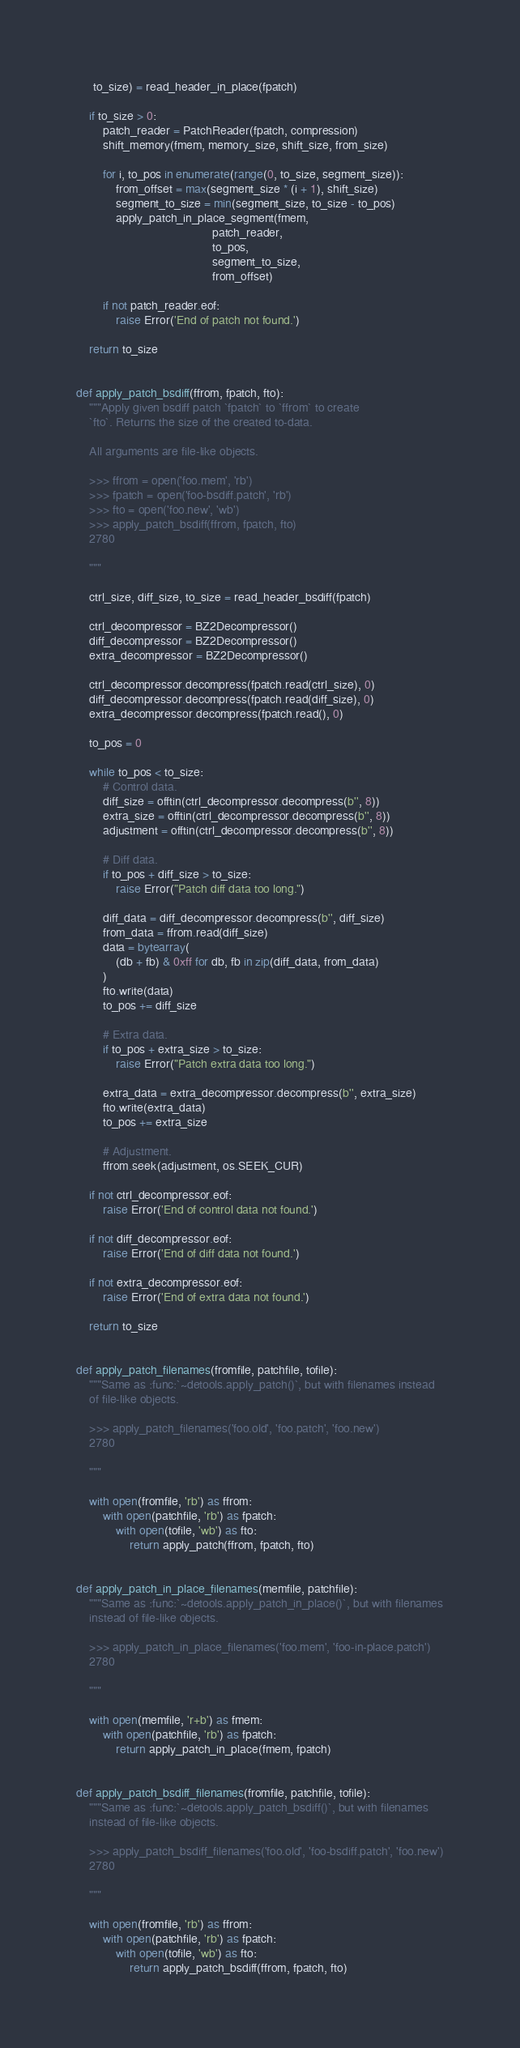Convert code to text. <code><loc_0><loc_0><loc_500><loc_500><_Python_>     to_size) = read_header_in_place(fpatch)

    if to_size > 0:
        patch_reader = PatchReader(fpatch, compression)
        shift_memory(fmem, memory_size, shift_size, from_size)

        for i, to_pos in enumerate(range(0, to_size, segment_size)):
            from_offset = max(segment_size * (i + 1), shift_size)
            segment_to_size = min(segment_size, to_size - to_pos)
            apply_patch_in_place_segment(fmem,
                                         patch_reader,
                                         to_pos,
                                         segment_to_size,
                                         from_offset)

        if not patch_reader.eof:
            raise Error('End of patch not found.')

    return to_size


def apply_patch_bsdiff(ffrom, fpatch, fto):
    """Apply given bsdiff patch `fpatch` to `ffrom` to create
    `fto`. Returns the size of the created to-data.

    All arguments are file-like objects.

    >>> ffrom = open('foo.mem', 'rb')
    >>> fpatch = open('foo-bsdiff.patch', 'rb')
    >>> fto = open('foo.new', 'wb')
    >>> apply_patch_bsdiff(ffrom, fpatch, fto)
    2780

    """

    ctrl_size, diff_size, to_size = read_header_bsdiff(fpatch)

    ctrl_decompressor = BZ2Decompressor()
    diff_decompressor = BZ2Decompressor()
    extra_decompressor = BZ2Decompressor()

    ctrl_decompressor.decompress(fpatch.read(ctrl_size), 0)
    diff_decompressor.decompress(fpatch.read(diff_size), 0)
    extra_decompressor.decompress(fpatch.read(), 0)

    to_pos = 0

    while to_pos < to_size:
        # Control data.
        diff_size = offtin(ctrl_decompressor.decompress(b'', 8))
        extra_size = offtin(ctrl_decompressor.decompress(b'', 8))
        adjustment = offtin(ctrl_decompressor.decompress(b'', 8))

        # Diff data.
        if to_pos + diff_size > to_size:
            raise Error("Patch diff data too long.")

        diff_data = diff_decompressor.decompress(b'', diff_size)
        from_data = ffrom.read(diff_size)
        data = bytearray(
            (db + fb) & 0xff for db, fb in zip(diff_data, from_data)
        )
        fto.write(data)
        to_pos += diff_size

        # Extra data.
        if to_pos + extra_size > to_size:
            raise Error("Patch extra data too long.")

        extra_data = extra_decompressor.decompress(b'', extra_size)
        fto.write(extra_data)
        to_pos += extra_size

        # Adjustment.
        ffrom.seek(adjustment, os.SEEK_CUR)

    if not ctrl_decompressor.eof:
        raise Error('End of control data not found.')

    if not diff_decompressor.eof:
        raise Error('End of diff data not found.')

    if not extra_decompressor.eof:
        raise Error('End of extra data not found.')

    return to_size


def apply_patch_filenames(fromfile, patchfile, tofile):
    """Same as :func:`~detools.apply_patch()`, but with filenames instead
    of file-like objects.

    >>> apply_patch_filenames('foo.old', 'foo.patch', 'foo.new')
    2780

    """

    with open(fromfile, 'rb') as ffrom:
        with open(patchfile, 'rb') as fpatch:
            with open(tofile, 'wb') as fto:
                return apply_patch(ffrom, fpatch, fto)


def apply_patch_in_place_filenames(memfile, patchfile):
    """Same as :func:`~detools.apply_patch_in_place()`, but with filenames
    instead of file-like objects.

    >>> apply_patch_in_place_filenames('foo.mem', 'foo-in-place.patch')
    2780

    """

    with open(memfile, 'r+b') as fmem:
        with open(patchfile, 'rb') as fpatch:
            return apply_patch_in_place(fmem, fpatch)


def apply_patch_bsdiff_filenames(fromfile, patchfile, tofile):
    """Same as :func:`~detools.apply_patch_bsdiff()`, but with filenames
    instead of file-like objects.

    >>> apply_patch_bsdiff_filenames('foo.old', 'foo-bsdiff.patch', 'foo.new')
    2780

    """

    with open(fromfile, 'rb') as ffrom:
        with open(patchfile, 'rb') as fpatch:
            with open(tofile, 'wb') as fto:
                return apply_patch_bsdiff(ffrom, fpatch, fto)
</code> 